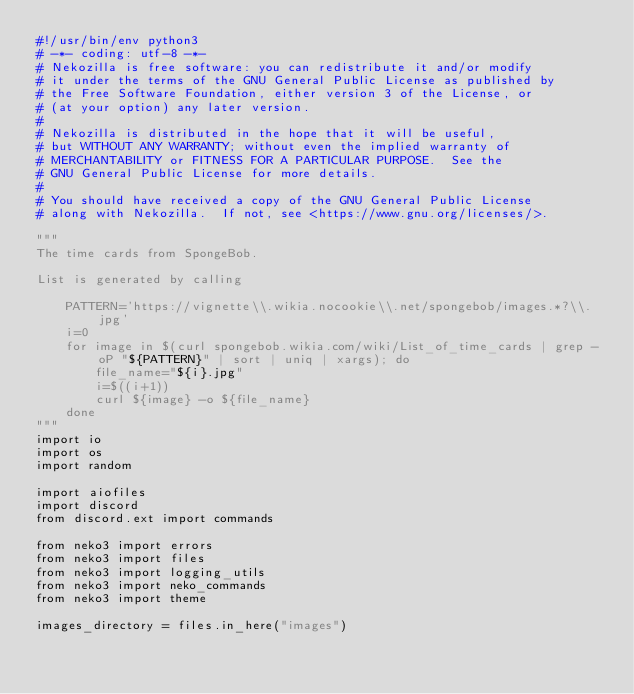Convert code to text. <code><loc_0><loc_0><loc_500><loc_500><_Python_>#!/usr/bin/env python3
# -*- coding: utf-8 -*-
# Nekozilla is free software: you can redistribute it and/or modify
# it under the terms of the GNU General Public License as published by
# the Free Software Foundation, either version 3 of the License, or
# (at your option) any later version.
#
# Nekozilla is distributed in the hope that it will be useful,
# but WITHOUT ANY WARRANTY; without even the implied warranty of
# MERCHANTABILITY or FITNESS FOR A PARTICULAR PURPOSE.  See the
# GNU General Public License for more details.
#
# You should have received a copy of the GNU General Public License
# along with Nekozilla.  If not, see <https://www.gnu.org/licenses/>.

"""
The time cards from SpongeBob.

List is generated by calling

    PATTERN='https://vignette\\.wikia.nocookie\\.net/spongebob/images.*?\\.jpg'
    i=0
    for image in $(curl spongebob.wikia.com/wiki/List_of_time_cards | grep -oP "${PATTERN}" | sort | uniq | xargs); do
        file_name="${i}.jpg"
        i=$((i+1))
        curl ${image} -o ${file_name}
    done
"""
import io
import os
import random

import aiofiles
import discord
from discord.ext import commands

from neko3 import errors
from neko3 import files
from neko3 import logging_utils
from neko3 import neko_commands
from neko3 import theme

images_directory = files.in_here("images")

</code> 